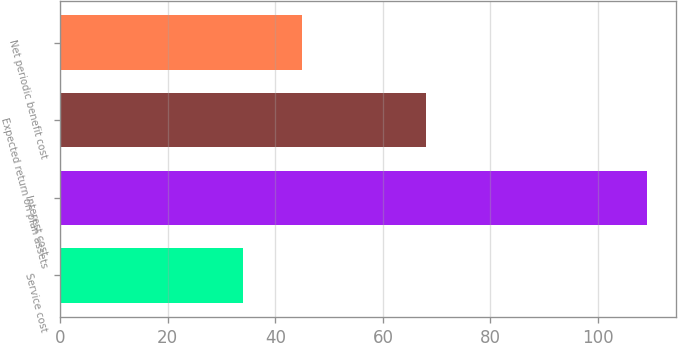Convert chart to OTSL. <chart><loc_0><loc_0><loc_500><loc_500><bar_chart><fcel>Service cost<fcel>Interest cost<fcel>Expected return on plan assets<fcel>Net periodic benefit cost<nl><fcel>34<fcel>109<fcel>68<fcel>45<nl></chart> 